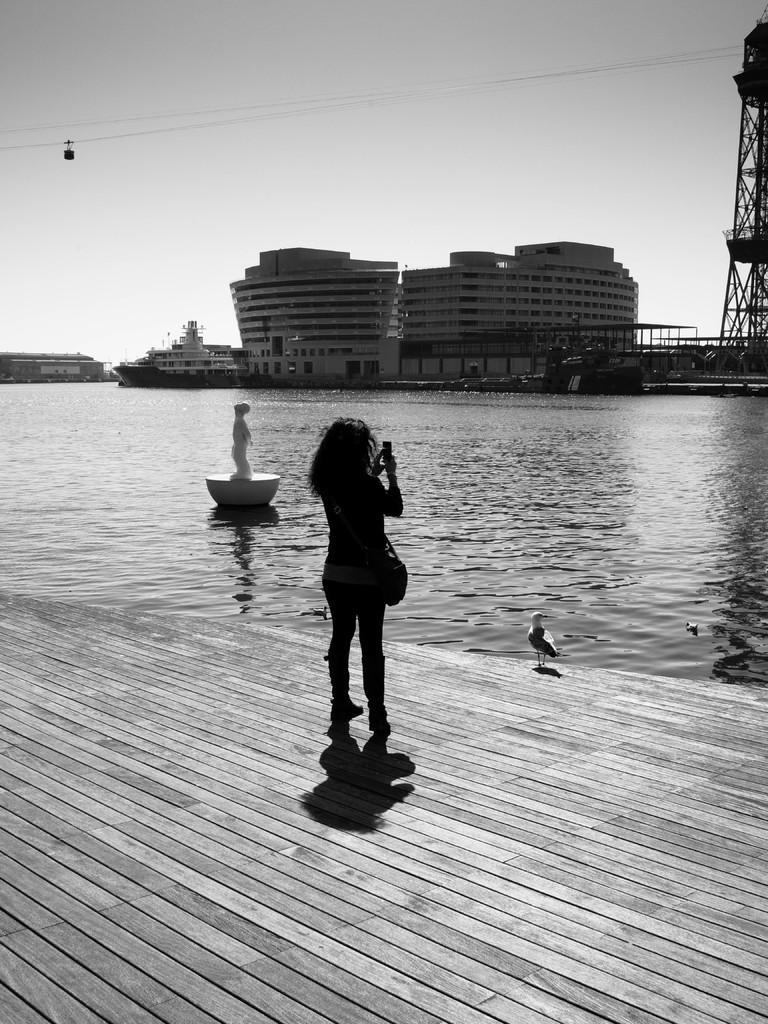Describe this image in one or two sentences. In this picture there is a girl standing on this wooden floor. We can observe a statue on this water. There is a river here. In the background there are buildings, a tower and a sky here. 